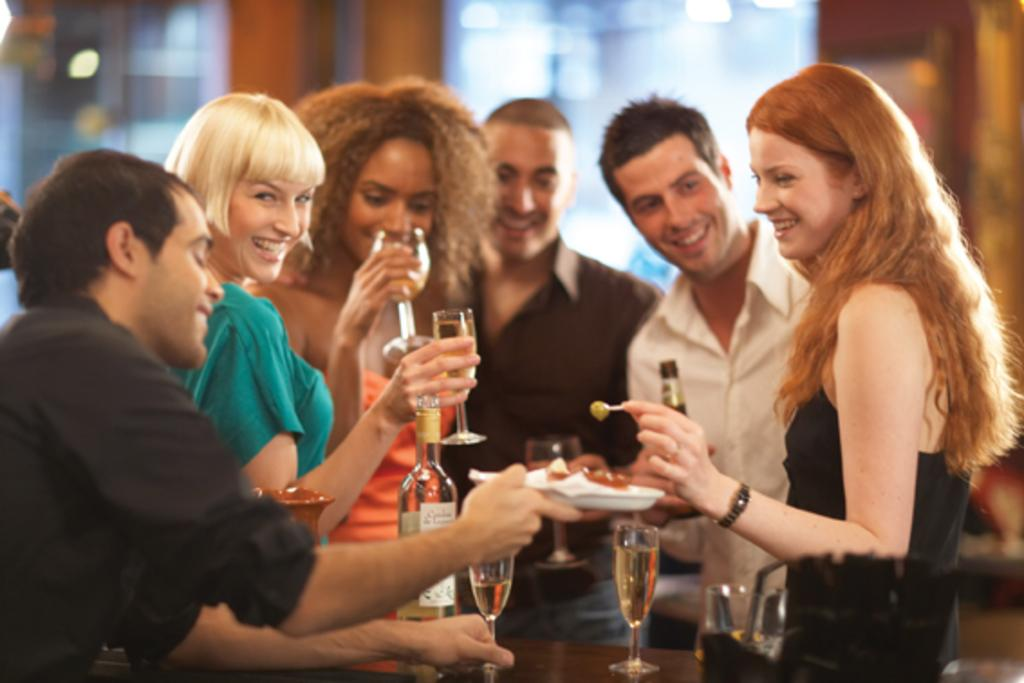What can be seen in the image? There is a group of people in the image. How are the people in the image feeling? The people are smiling in the image. What are the people holding in the image? The people are holding objects in the image. Can you describe the background of the image? The background of the image is blurred. What type of legal advice is the lawyer providing in the image? There is no lawyer present in the image, so it is not possible to determine what legal advice might be provided. 